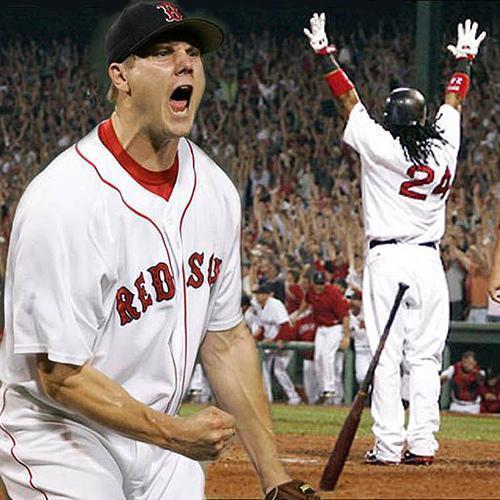How many people are there?
Give a very brief answer. 3. How many pieces of chocolate cake are on the white plate?
Give a very brief answer. 0. 